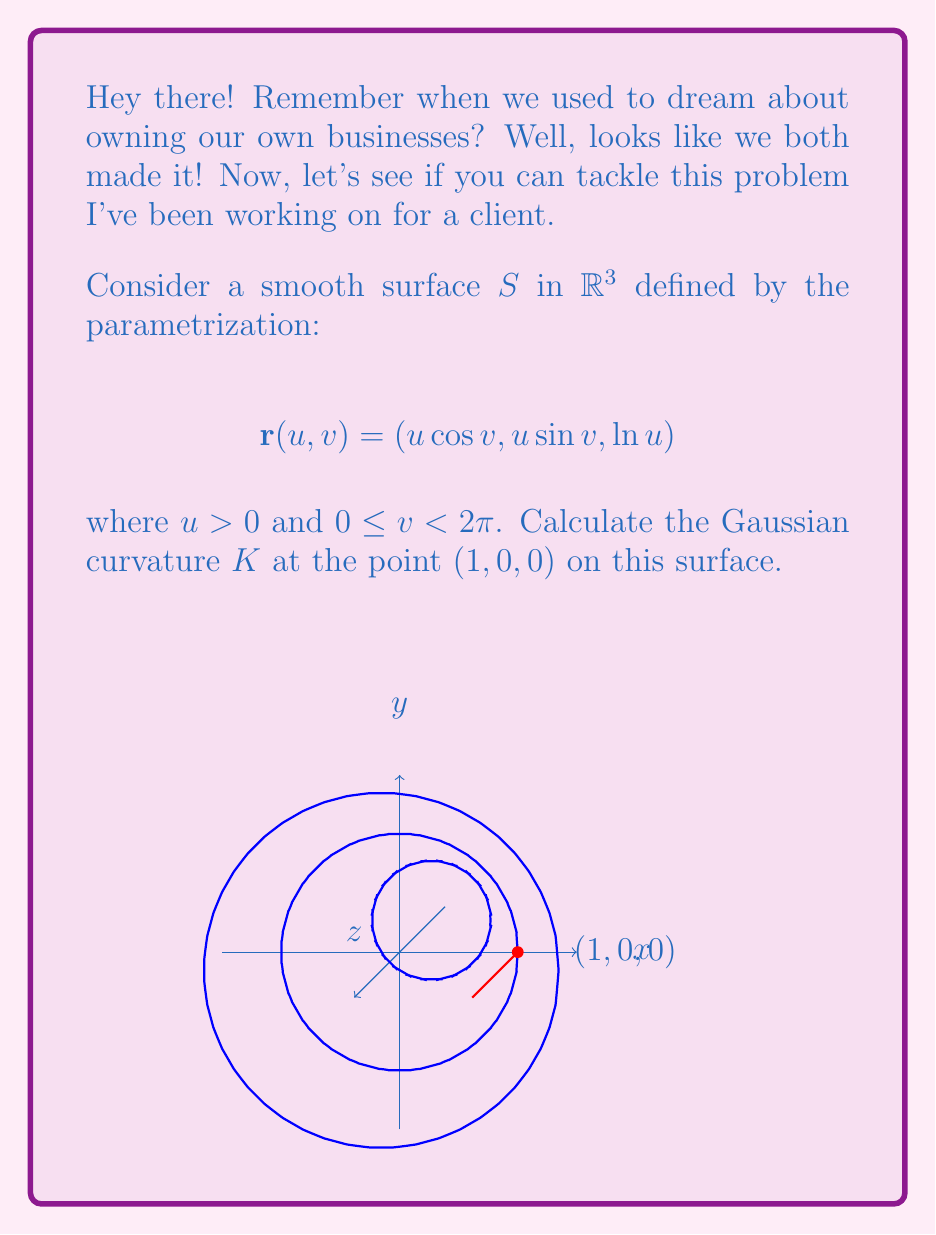Help me with this question. Let's approach this step-by-step:

1) To calculate the Gaussian curvature, we need to find the coefficients of the first and second fundamental forms.

2) First, let's calculate the partial derivatives:
   $$\mathbf{r}_u = (\cos v, \sin v, \frac{1}{u})$$
   $$\mathbf{r}_v = (-u\sin v, u\cos v, 0)$$

3) Now, let's calculate the coefficients of the first fundamental form:
   $$E = \mathbf{r}_u \cdot \mathbf{r}_u = \cos^2 v + \sin^2 v + \frac{1}{u^2} = 1 + \frac{1}{u^2}$$
   $$F = \mathbf{r}_u \cdot \mathbf{r}_v = 0$$
   $$G = \mathbf{r}_v \cdot \mathbf{r}_v = u^2$$

4) Next, we need the second partial derivatives:
   $$\mathbf{r}_{uu} = (0, 0, -\frac{1}{u^2})$$
   $$\mathbf{r}_{uv} = (-\sin v, \cos v, 0)$$
   $$\mathbf{r}_{vv} = (-u\cos v, -u\sin v, 0)$$

5) Now we can calculate the unit normal vector:
   $$\mathbf{N} = \frac{\mathbf{r}_u \times \mathbf{r}_v}{|\mathbf{r}_u \times \mathbf{r}_v|} = \frac{(-\sin v, -\cos v, u)}{\sqrt{u^2 + 1}}$$

6) We can now calculate the coefficients of the second fundamental form:
   $$L = \mathbf{r}_{uu} \cdot \mathbf{N} = \frac{-u}{u^2\sqrt{u^2 + 1}}$$
   $$M = \mathbf{r}_{uv} \cdot \mathbf{N} = 0$$
   $$N = \mathbf{r}_{vv} \cdot \mathbf{N} = \frac{u^2}{\sqrt{u^2 + 1}}$$

7) The Gaussian curvature is given by:
   $$K = \frac{LN - M^2}{EG - F^2}$$

8) Substituting our calculated values:
   $$K = \frac{(\frac{-u}{u^2\sqrt{u^2 + 1}})(\frac{u^2}{\sqrt{u^2 + 1}}) - 0^2}{(1 + \frac{1}{u^2})(u^2) - 0^2} = \frac{-1}{u^2(u^2 + 1)}$$

9) At the point (1, 0, 0), we have u = 1. Substituting this:
   $$K = \frac{-1}{1^2(1^2 + 1)} = -\frac{1}{2}$$

Therefore, the Gaussian curvature at the point (1, 0, 0) is -1/2.
Answer: $K = -\frac{1}{2}$ 